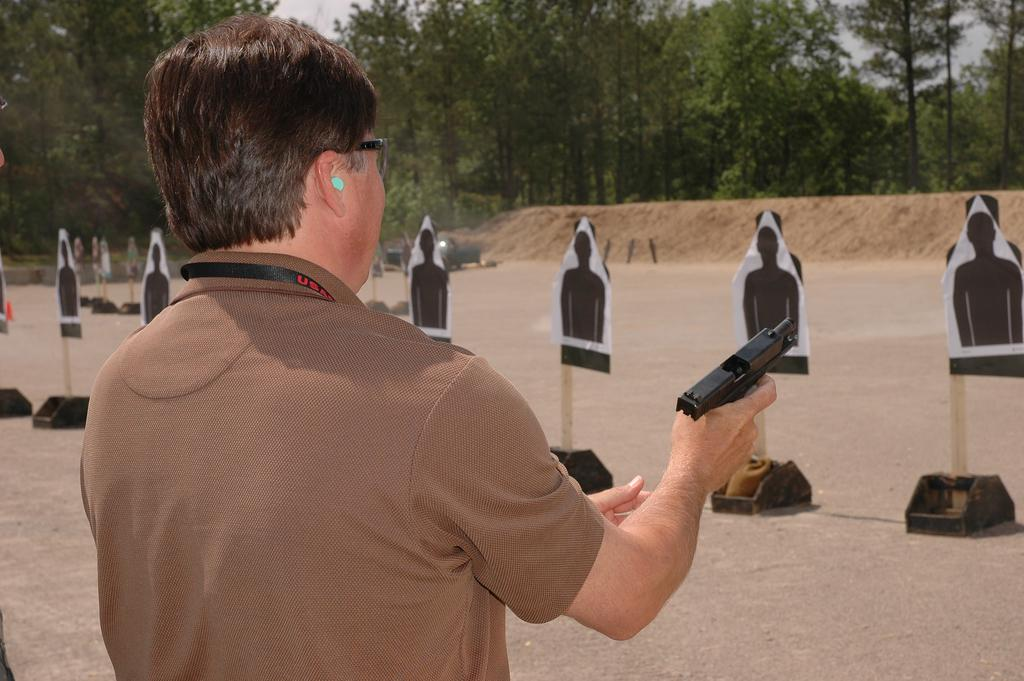What is the main subject in the image? There is a person in the image. What is the person holding in the image? The person is holding an object. What can be seen on the ground in the image? There are objects on the ground in the image. What type of activity is suggested by the presence of gun shooting boards in the image? The presence of gun shooting boards suggests that the person might be participating in target practice or a shooting activity. What type of natural environment is visible in the image? There are trees visible in the image, indicating a wooded or outdoor setting. What is visible in the sky in the image? The sky is visible in the image, providing context for the time of day or weather conditions. What type of appliance is being used to burn the trees in the image? There is no appliance or burning of trees present in the image. 